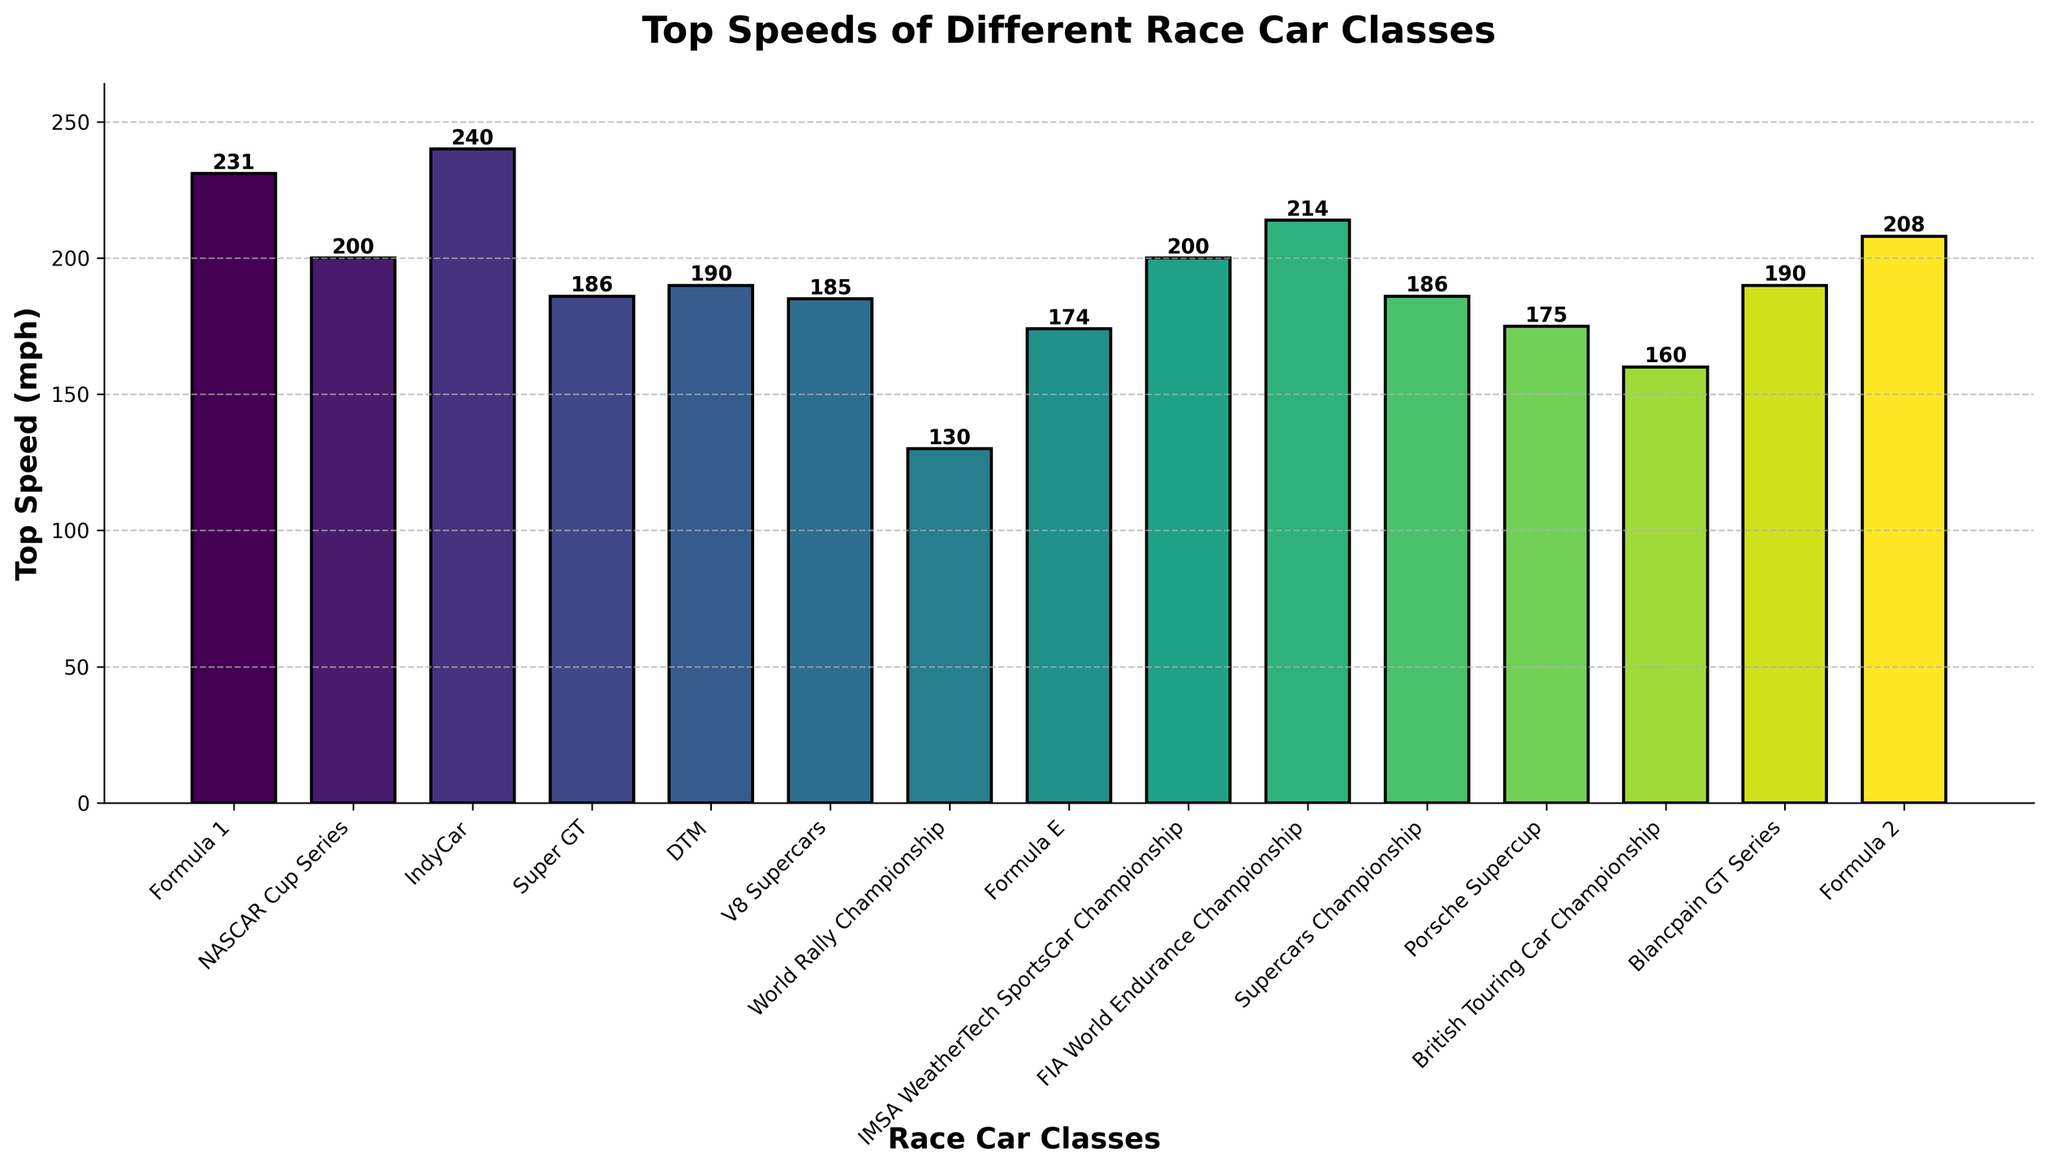Which race car class has the highest top speed? The top speed is indicated by the tallest bar on the chart. The tallest bar represents IndyCar with a top speed of 240 mph.
Answer: IndyCar Which race car class has the lowest top speed? The shortest bar on the chart represents the race car class with the lowest top speed. The shortest bar corresponds to the World Rally Championship with a top speed of 130 mph.
Answer: World Rally Championship What is the difference in top speed between Formula 1 and Formula 2 cars? The top speed for Formula 1 is 231 mph and for Formula 2 is 208 mph. The difference can be calculated as 231 mph - 208 mph = 23 mph.
Answer: 23 mph How many race car classes have a top speed greater than 200 mph? Counting the bars with a height corresponding to a top speed greater than 200 mph identifies Formula 1, IndyCar, FIA World Endurance Championship, and Formula 2, totaling 4 classes.
Answer: 4 What is the average top speed of all the classes? Summing all top speeds (231 + 200 + 240 + 186 + 190 + 185 + 130 + 174 + 200 + 214 + 186 + 175 + 160 + 190 + 208) and dividing by the number of classes (15) gives (2979 / 15) = 198.6 mph.
Answer: 198.6 mph Which race car classes have a top speed between 180 mph and 200 mph? Identifying bars with top speeds in this range include Super GT (186 mph), DTM (190 mph), V8 Supercars (185 mph), Supercars Championship (186 mph), and Blancpain GT Series (190 mph), totaling 5 classes.
Answer: Super GT, DTM, V8 Supercars, Supercars Championship, Blancpain GT Series Which class has the closest top speed to Formula E? Formula E has a top speed of 174 mph. Comparing visually, the class closest in height is Porsche Supercup with a top speed of 175 mph.
Answer: Porsche Supercup 